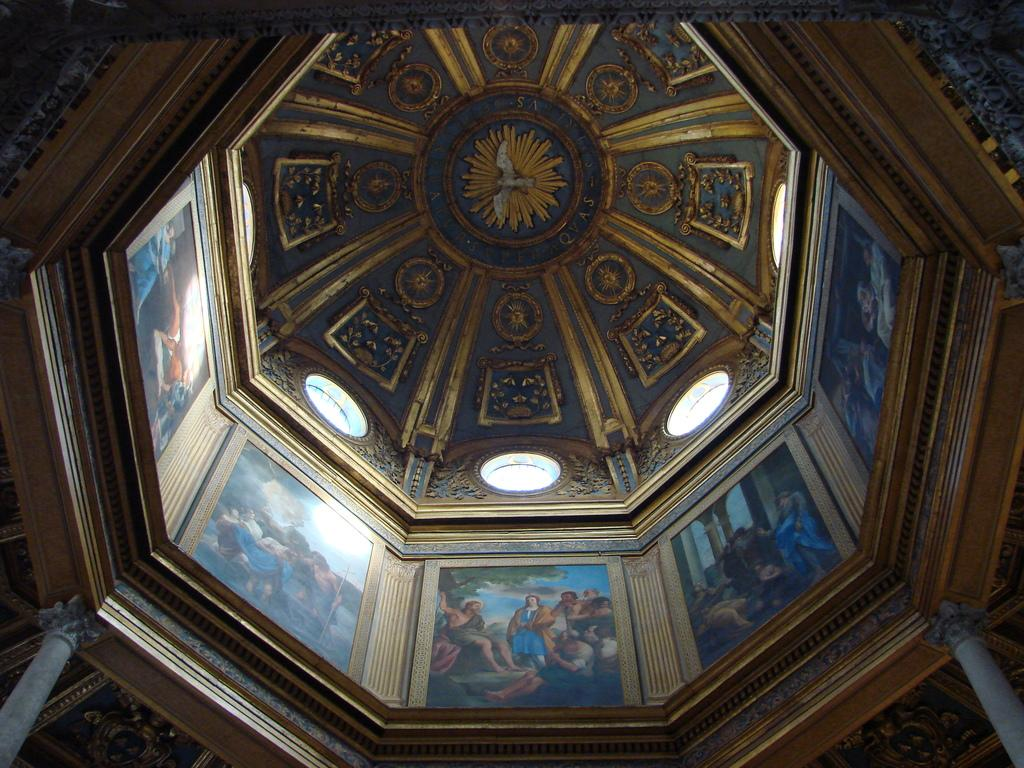What type of location is shown in the image? The image depicts the interior of a building. What can be seen on the walls of the building? There are paintings and decorations on the walls. Are there any architectural features visible in the image? Yes, there are pillars in the image. Can you describe the tiger's tongue in the image? There is no tiger present in the image, so it is not possible to describe its tongue. 